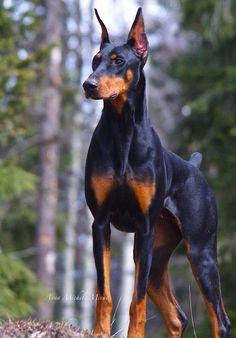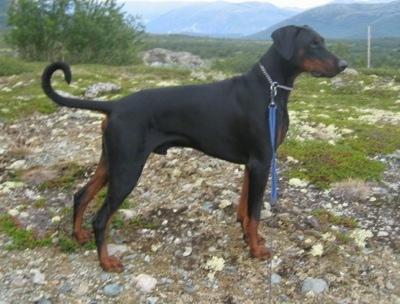The first image is the image on the left, the second image is the image on the right. For the images shown, is this caption "The left image shows a doberman with erect ears and docked tail standing with his chest facing forward in front of at least one tall tree." true? Answer yes or no. Yes. 